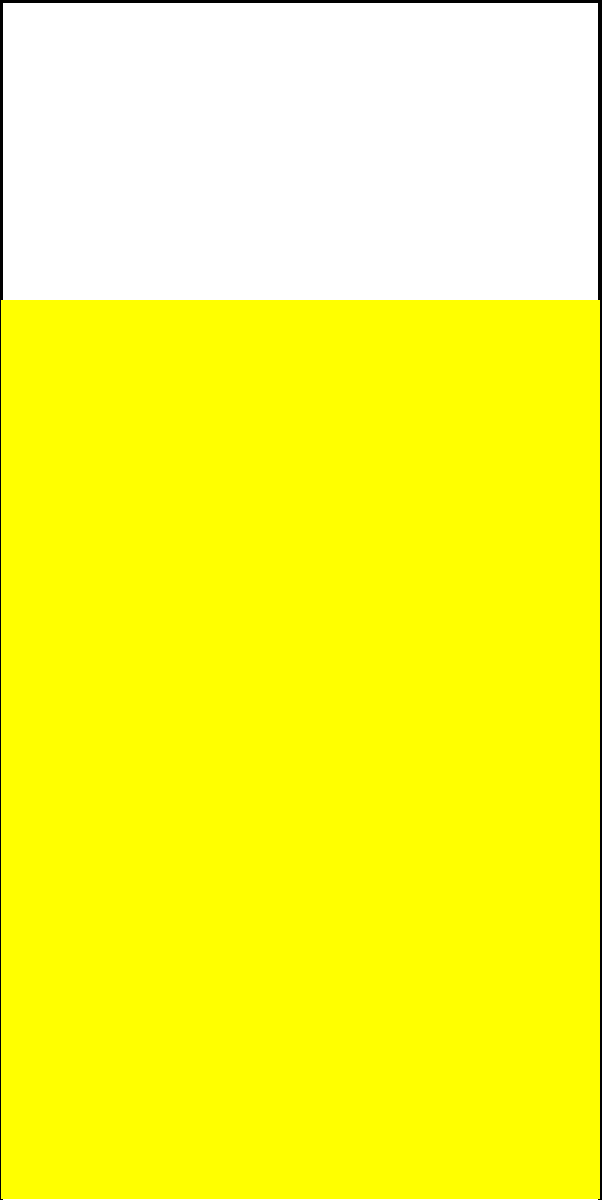As a beer enthusiast participating in a gut health study, you're intrigued by the physics of carbonation. In a glass of your favorite craft beer, a bubble with a radius of 0.5 mm is rising. The density of the beer is 1030 kg/m³, and the bubble's upward velocity is 0.1 m/s. Assuming the temperature is 20°C and atmospheric pressure is 101.325 kPa, calculate the net upward force acting on the bubble. (Hint: Consider buoyant force, drag force, and gravitational force. Use $g = 9.81$ m/s² and the drag coefficient $C_d = 0.47$ for a sphere.) Let's approach this step-by-step:

1) First, calculate the volume of the bubble:
   $V = \frac{4}{3}\pi r^3 = \frac{4}{3}\pi (0.5 \times 10^{-3})^3 = 5.236 \times 10^{-10}$ m³

2) Calculate the mass of the air in the bubble using the ideal gas law:
   $PV = nRT$, where $n = \frac{m}{M}$
   $m = \frac{PVM}{RT}$
   $m = \frac{101325 \times 5.236 \times 10^{-10} \times 0.029}{8.314 \times 293} = 6.277 \times 10^{-10}$ kg

3) Calculate the buoyant force:
   $F_b = \rho_{beer}Vg = 1030 \times 5.236 \times 10^{-10} \times 9.81 = 5.297 \times 10^{-6}$ N

4) Calculate the gravitational force:
   $F_g = mg = 6.277 \times 10^{-10} \times 9.81 = 6.158 \times 10^{-9}$ N

5) Calculate the drag force:
   $F_d = \frac{1}{2}C_d\rho_{beer}Av^2$
   where $A = \pi r^2 = \pi (0.5 \times 10^{-3})^2 = 7.854 \times 10^{-7}$ m²
   $F_d = \frac{1}{2} \times 0.47 \times 1030 \times 7.854 \times 10^{-7} \times 0.1^2 = 1.900 \times 10^{-6}$ N

6) The net upward force is:
   $F_{net} = F_b - F_d - F_g = 5.297 \times 10^{-6} - 1.900 \times 10^{-6} - 6.158 \times 10^{-9} = 3.391 \times 10^{-6}$ N
Answer: $3.391 \times 10^{-6}$ N 